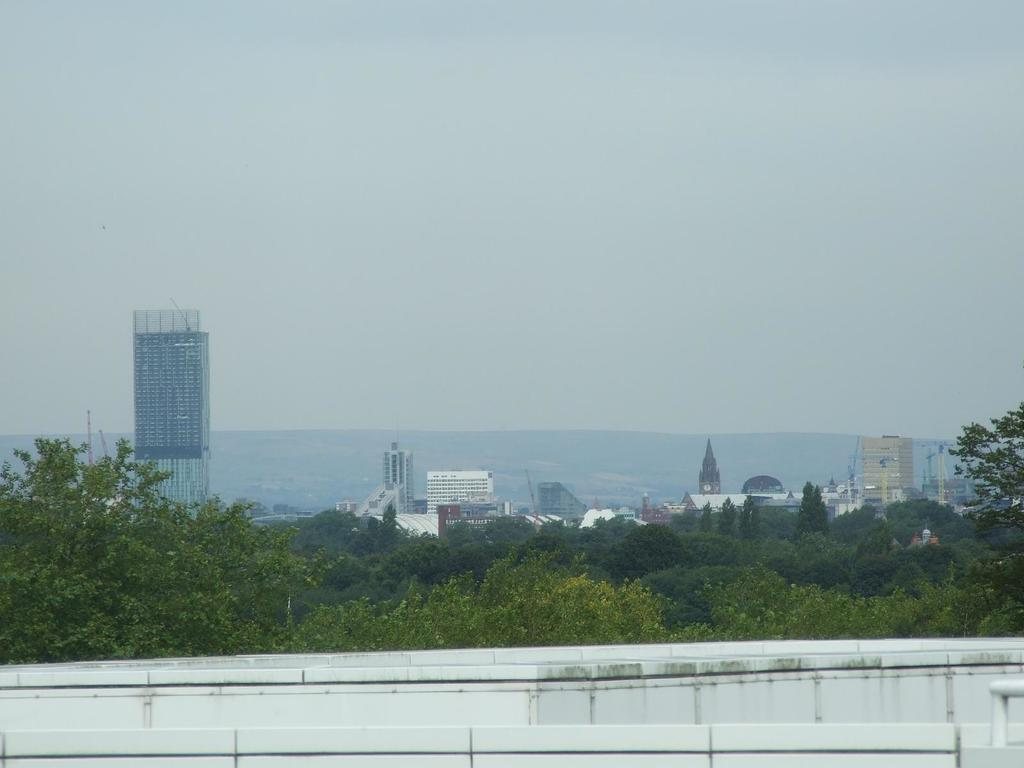What can be seen in the foreground of the image? There are objects in the foreground of the image. What type of natural scenery is visible in the background of the image? There are trees in the background of the image. What type of man-made structures can be seen in the background of the image? There are buildings in the background of the image. What type of geographical feature is visible in the background of the image? There are mountains in the background of the image. What type of underwear is hanging on the trees in the image? There is no underwear present in the image; it only features trees, buildings, and mountains in the background. How many eggs are visible on the buildings in the image? There are no eggs visible on the buildings in the image; it only features buildings, trees, and mountains in the background. 